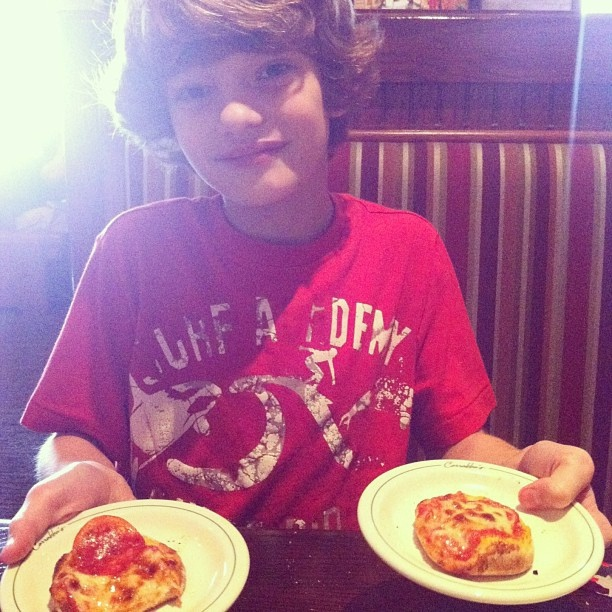Describe the objects in this image and their specific colors. I can see people in beige, purple, brown, and violet tones, chair in beige, purple, and lavender tones, chair in beige and purple tones, dining table in beige, purple, brown, and tan tones, and pizza in beige, orange, salmon, brown, and red tones in this image. 